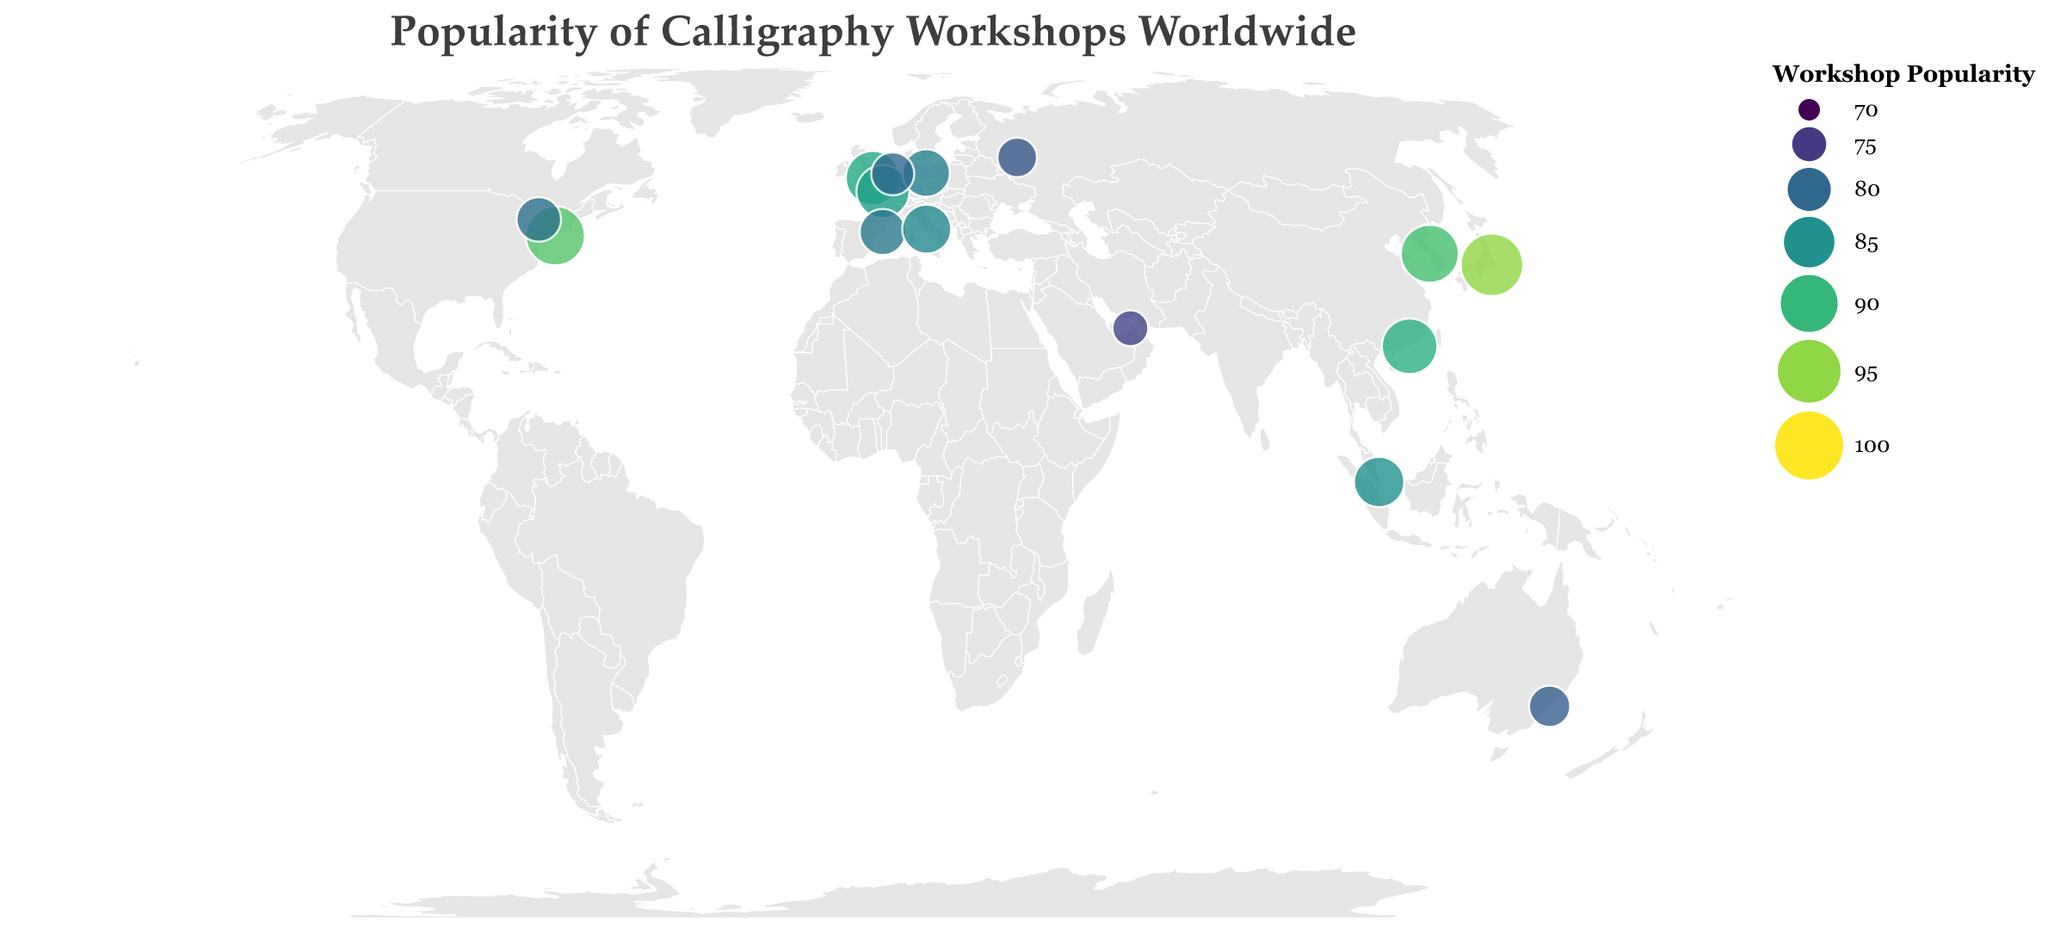What is the title of the figure? The title is located at the top of the figure in a larger font and clearly states the main topic of the visualization.
Answer: Popularity of Calligraphy Workshops Worldwide Which city has the highest popularity for calligraphy workshops? The popularity level can be identified by looking at the largest and darkest colored circles on the map.
Answer: Tokyo What is the workshop popularity of Berlin? By referring to the tooltip or locating the size and color of the circle representing Berlin on the map, the popularity value can be identified.
Answer: 83 Are there any cities in the southern hemisphere represented on the map? The southern hemisphere is situated below the equator (0 degrees latitude). Examine the map to identify cities below this line.
Answer: Yes, Sydney Which city has a higher workshop popularity, Paris or Rome? Compare the colors and sizes of the circles representing Paris and Rome, and refer to the tooltip for exact values.
Answer: Paris What's the average workshop popularity of the cities in North America? North American cities in the data are New York and Toronto. Calculate the average by summing their popularity scores and dividing by 2: (92 + 81) / 2.
Answer: 86.5 Which continent has the most cities represented in the figure? Count the number of cities located in each continent based on their geographic coordinates.
Answer: Europe Does Moscow have a higher workshop popularity than Sydney? Compare the popularity values of Moscow and Sydney by looking at the corresponding circles on the map.
Answer: No What is the range of workshop popularity values across all cities? The range is determined by subtracting the lowest popularity value from the highest popularity value among all cities.
Answer: 95 - 76 = 19 Which city in Asia has the lowest workshop popularity? Identify the Asian cities on the map, examine their popularity values, and find the lowest one.
Answer: Dubai 